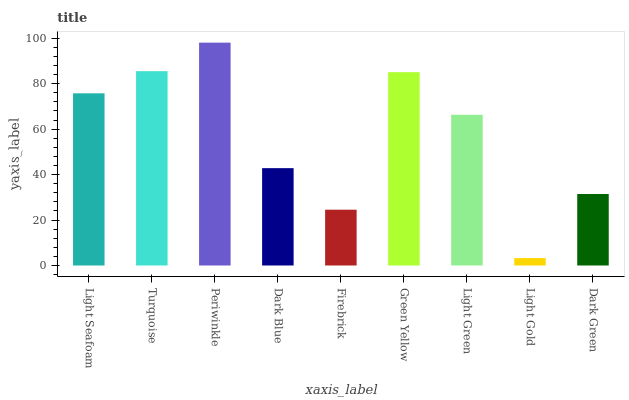Is Turquoise the minimum?
Answer yes or no. No. Is Turquoise the maximum?
Answer yes or no. No. Is Turquoise greater than Light Seafoam?
Answer yes or no. Yes. Is Light Seafoam less than Turquoise?
Answer yes or no. Yes. Is Light Seafoam greater than Turquoise?
Answer yes or no. No. Is Turquoise less than Light Seafoam?
Answer yes or no. No. Is Light Green the high median?
Answer yes or no. Yes. Is Light Green the low median?
Answer yes or no. Yes. Is Firebrick the high median?
Answer yes or no. No. Is Firebrick the low median?
Answer yes or no. No. 